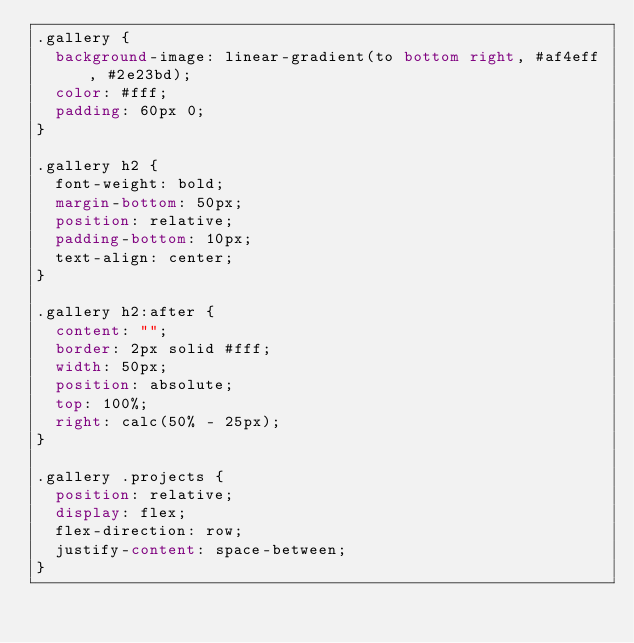Convert code to text. <code><loc_0><loc_0><loc_500><loc_500><_CSS_>.gallery {
  background-image: linear-gradient(to bottom right, #af4eff, #2e23bd);
  color: #fff;
  padding: 60px 0;
}

.gallery h2 {
  font-weight: bold;
  margin-bottom: 50px;
  position: relative;
  padding-bottom: 10px;
  text-align: center;
}

.gallery h2:after {
  content: "";
  border: 2px solid #fff;
  width: 50px;
  position: absolute;
  top: 100%;
  right: calc(50% - 25px);
}

.gallery .projects {
  position: relative;
  display: flex;
  flex-direction: row;
  justify-content: space-between;
}
</code> 